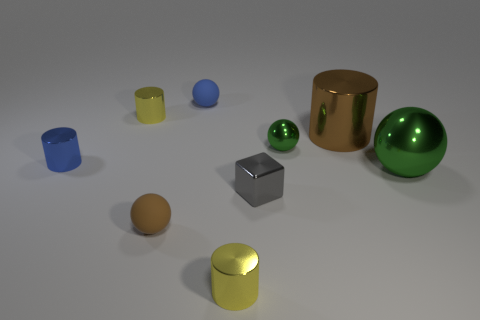Subtract 1 cylinders. How many cylinders are left? 3 Add 1 small blue rubber things. How many objects exist? 10 Subtract all spheres. How many objects are left? 5 Subtract all spheres. Subtract all green cubes. How many objects are left? 5 Add 4 tiny blue metal things. How many tiny blue metal things are left? 5 Add 7 tiny yellow objects. How many tiny yellow objects exist? 9 Subtract 0 red blocks. How many objects are left? 9 